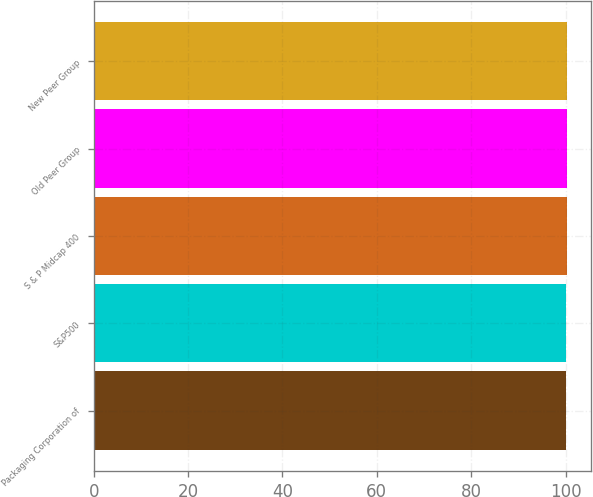Convert chart. <chart><loc_0><loc_0><loc_500><loc_500><bar_chart><fcel>Packaging Corporation of<fcel>S&P500<fcel>S & P Midcap 400<fcel>Old Peer Group<fcel>New Peer Group<nl><fcel>100<fcel>100.1<fcel>100.2<fcel>100.3<fcel>100.4<nl></chart> 